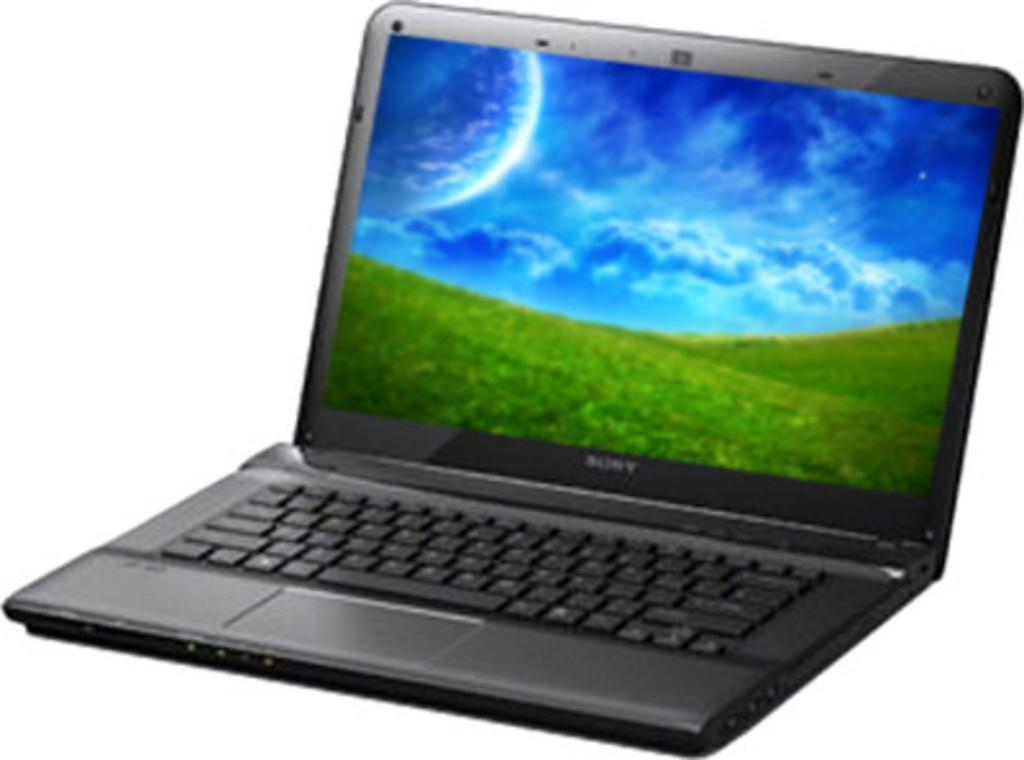<image>
Summarize the visual content of the image. a sony laptop is open and has a blue and green homescreen 